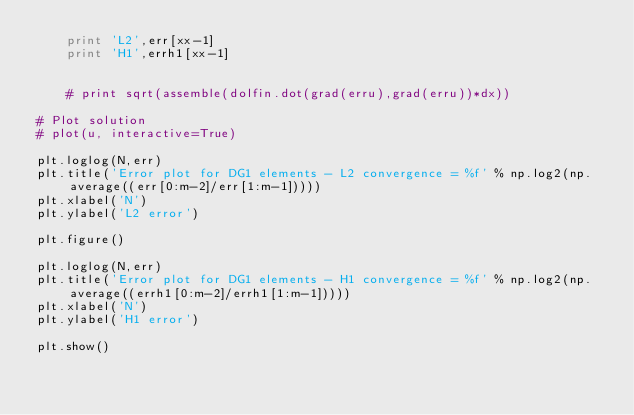Convert code to text. <code><loc_0><loc_0><loc_500><loc_500><_Python_>    print 'L2',err[xx-1]
    print 'H1',errh1[xx-1]


    # print sqrt(assemble(dolfin.dot(grad(erru),grad(erru))*dx))

# Plot solution
# plot(u, interactive=True)

plt.loglog(N,err)
plt.title('Error plot for DG1 elements - L2 convergence = %f' % np.log2(np.average((err[0:m-2]/err[1:m-1]))))
plt.xlabel('N')
plt.ylabel('L2 error')

plt.figure()

plt.loglog(N,err)
plt.title('Error plot for DG1 elements - H1 convergence = %f' % np.log2(np.average((errh1[0:m-2]/errh1[1:m-1]))))
plt.xlabel('N')
plt.ylabel('H1 error')

plt.show()</code> 